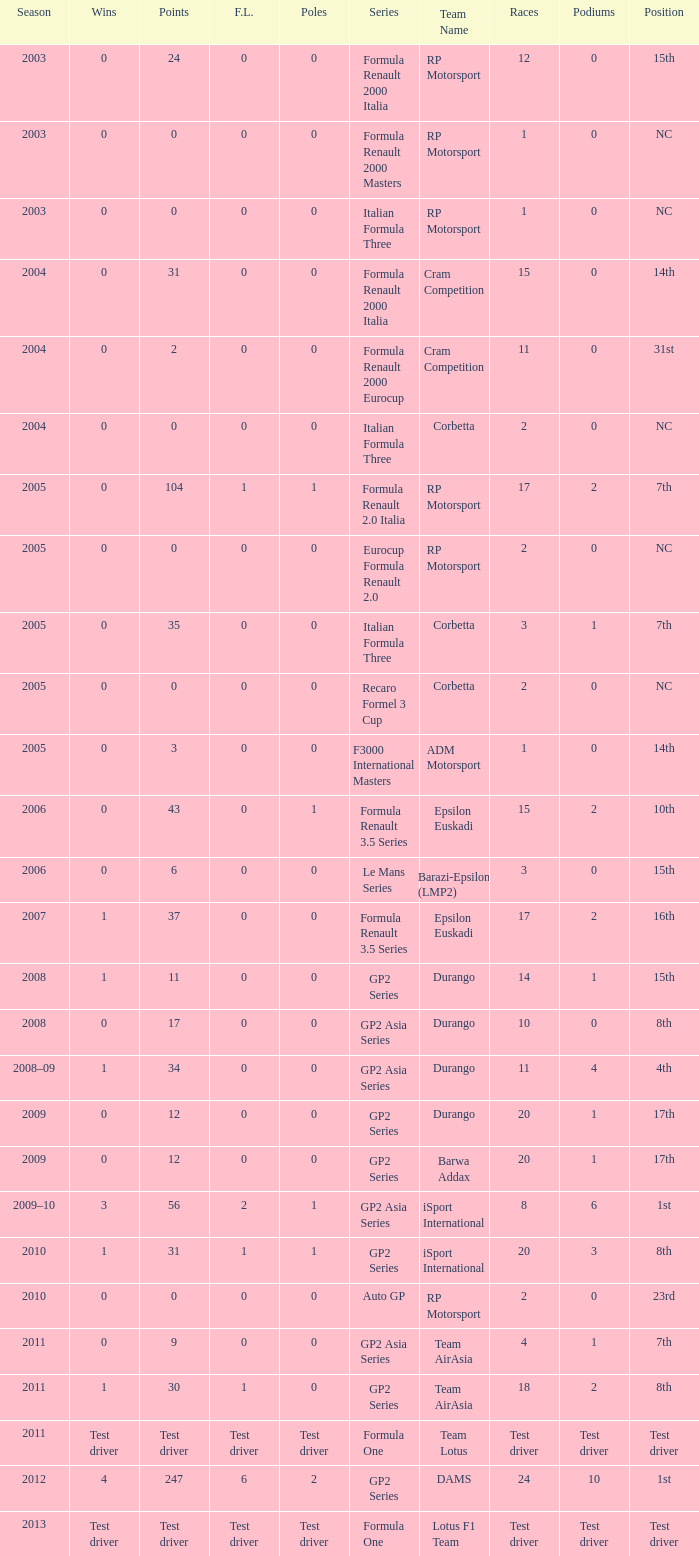What is the number of podiums with 0 wins and 6 points? 0.0. 